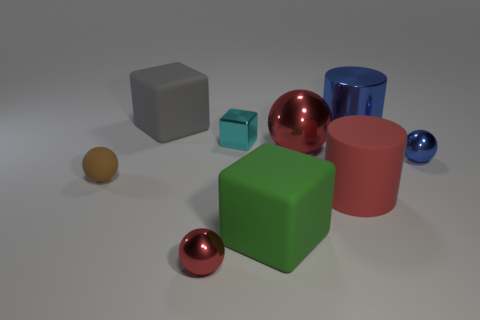Subtract all red balls. How many were subtracted if there are1red balls left? 1 Subtract all big gray cubes. How many cubes are left? 2 Subtract all purple cylinders. How many red spheres are left? 2 Subtract all balls. How many objects are left? 5 Subtract 1 cubes. How many cubes are left? 2 Subtract all brown balls. How many balls are left? 3 Subtract all purple balls. Subtract all blue cubes. How many balls are left? 4 Subtract 0 purple cubes. How many objects are left? 9 Subtract all large green cubes. Subtract all small blue balls. How many objects are left? 7 Add 6 green matte objects. How many green matte objects are left? 7 